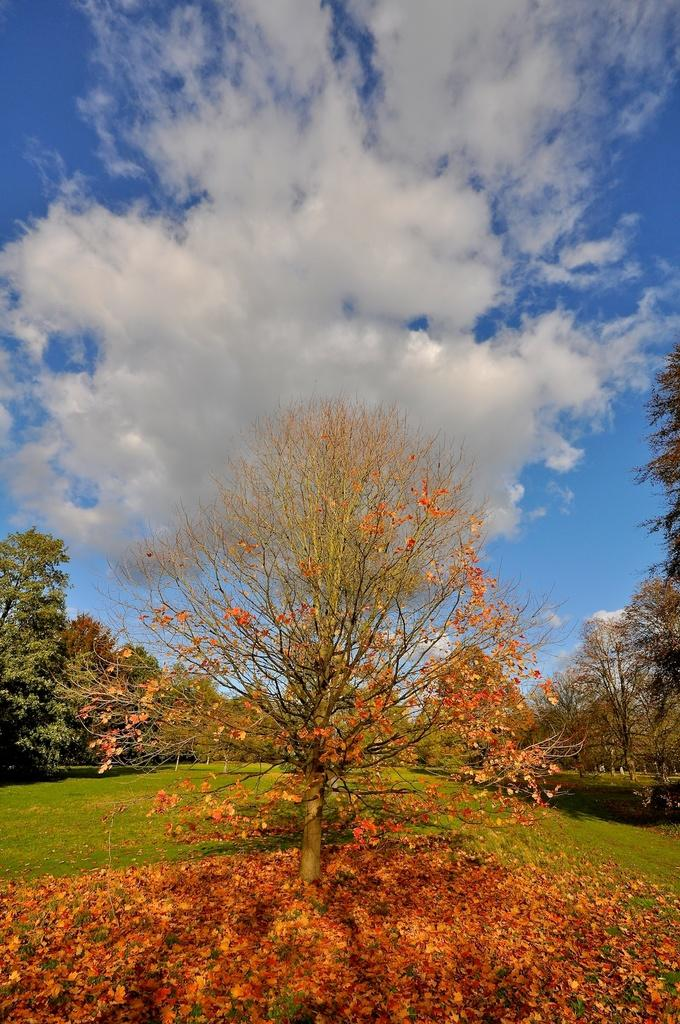What type of vegetation can be seen in the image? There are trees in the image. What is on the ground in the image? There are leaves and grass on the ground in the image. How would you describe the sky in the image? The sky is blue and cloudy in the image. Can you tell me where the locket is hanging from in the image? There is no locket present in the image. How many cobwebs can be seen in the image? There are no cobwebs visible in the image. 